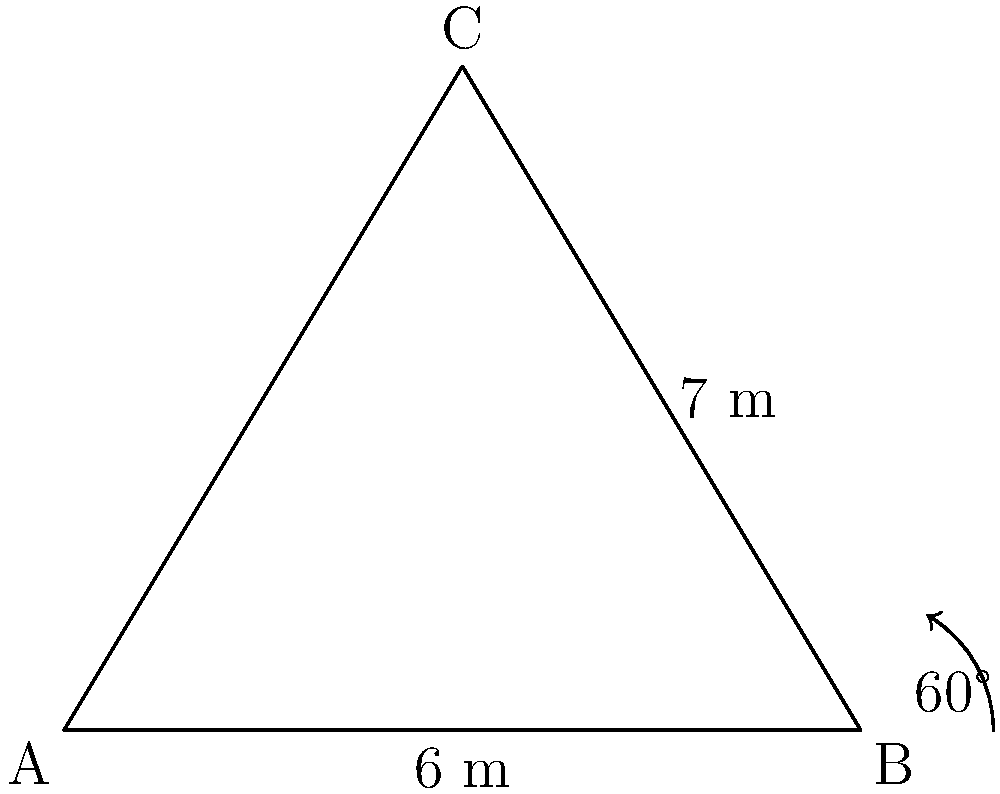During a Kathak performance at the Royal Albert Hall in London, you are part of a triangular formation. The base of the triangle is 6 meters, and one of the other sides is 7 meters. The angle between these two sides is 60°. Calculate the area of the triangular formation. To solve this problem, we'll use the formula for the area of a triangle given two sides and the included angle:

$$A = \frac{1}{2}ab\sin(C)$$

Where:
$A$ is the area of the triangle
$a$ and $b$ are the two known sides
$C$ is the angle between these sides

Given:
- $a = 6$ meters (base)
- $b = 7$ meters (side)
- $C = 60°$

Step 1: Substitute the values into the formula:
$$A = \frac{1}{2} \cdot 6 \cdot 7 \cdot \sin(60°)$$

Step 2: Calculate $\sin(60°)$:
$\sin(60°) = \frac{\sqrt{3}}{2}$

Step 3: Substitute this value:
$$A = \frac{1}{2} \cdot 6 \cdot 7 \cdot \frac{\sqrt{3}}{2}$$

Step 4: Simplify:
$$A = \frac{6 \cdot 7 \cdot \sqrt{3}}{4} = \frac{42\sqrt{3}}{4} = \frac{21\sqrt{3}}{2}$$

Step 5: Calculate the final value:
$$A \approx 18.19 \text{ m}^2$$
Answer: $\frac{21\sqrt{3}}{2} \text{ m}^2$ or approximately $18.19 \text{ m}^2$ 